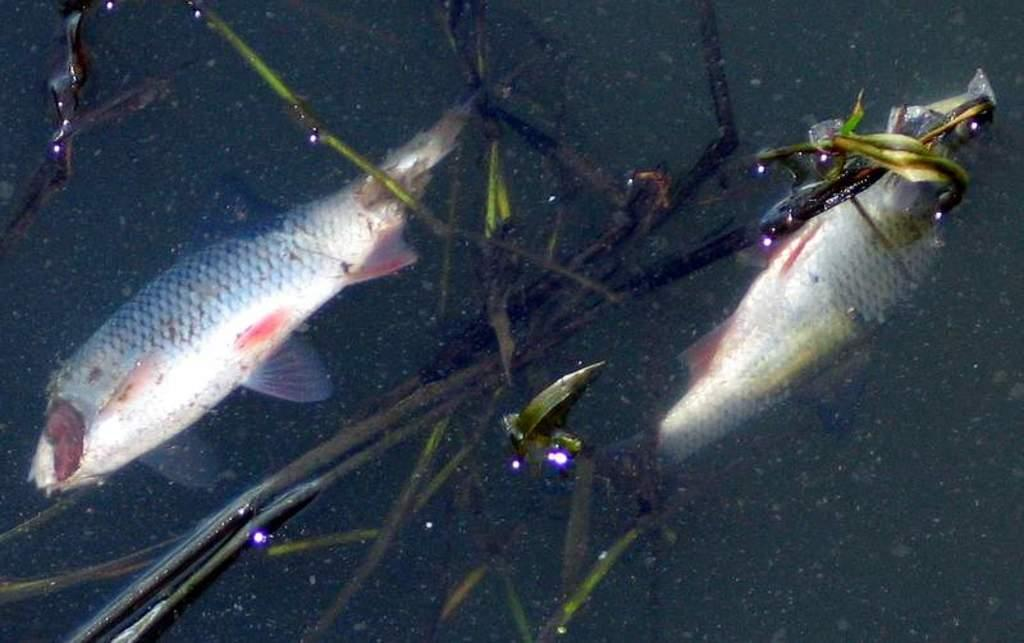What is the primary element visible in the image? There is water in the image. Are there any living organisms present in the image? Yes, there are two fishes on the surface of the water in the image. What other object can be seen in the image? There is a plant in the image. Where is the porter carrying the basket of fruits in the image? There is no porter or basket of fruits present in the image. How tall are the giants standing near the water in the image? There are no giants present in the image. 